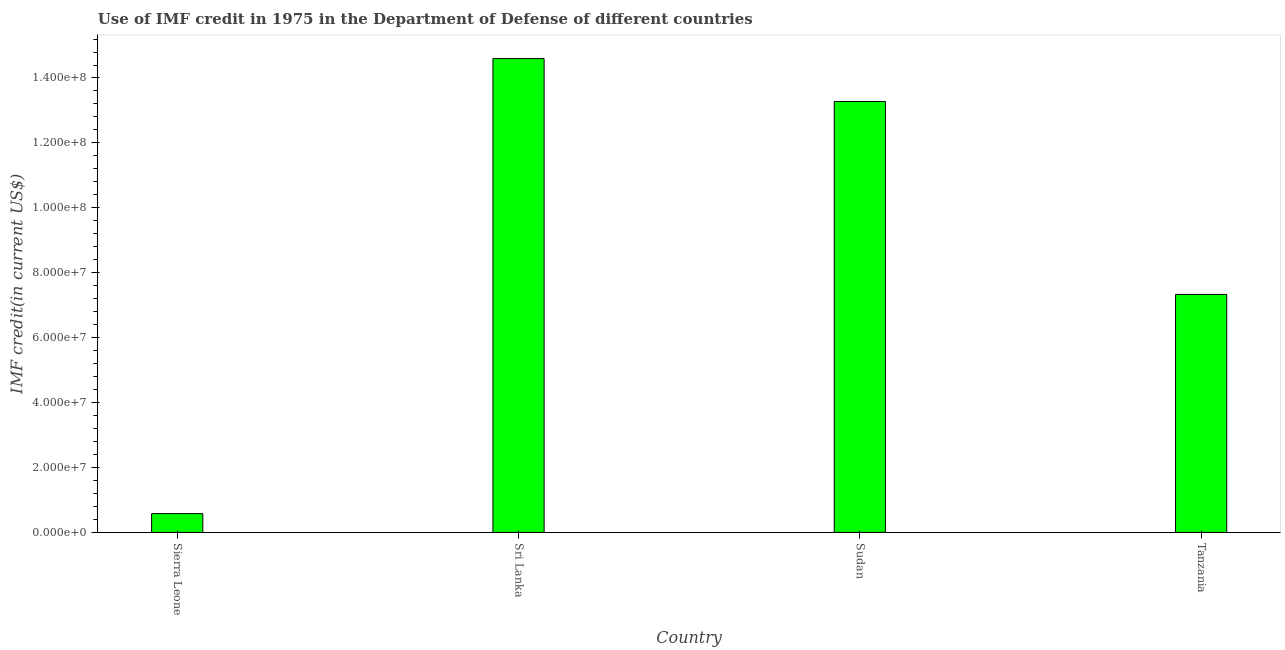Does the graph contain any zero values?
Keep it short and to the point. No. Does the graph contain grids?
Your answer should be very brief. No. What is the title of the graph?
Give a very brief answer. Use of IMF credit in 1975 in the Department of Defense of different countries. What is the label or title of the X-axis?
Make the answer very short. Country. What is the label or title of the Y-axis?
Your answer should be very brief. IMF credit(in current US$). What is the use of imf credit in dod in Sierra Leone?
Your answer should be very brief. 5.78e+06. Across all countries, what is the maximum use of imf credit in dod?
Your answer should be compact. 1.46e+08. Across all countries, what is the minimum use of imf credit in dod?
Offer a very short reply. 5.78e+06. In which country was the use of imf credit in dod maximum?
Your response must be concise. Sri Lanka. In which country was the use of imf credit in dod minimum?
Your answer should be compact. Sierra Leone. What is the sum of the use of imf credit in dod?
Provide a short and direct response. 3.58e+08. What is the difference between the use of imf credit in dod in Sudan and Tanzania?
Make the answer very short. 5.94e+07. What is the average use of imf credit in dod per country?
Ensure brevity in your answer.  8.95e+07. What is the median use of imf credit in dod?
Keep it short and to the point. 1.03e+08. What is the ratio of the use of imf credit in dod in Sierra Leone to that in Sudan?
Provide a succinct answer. 0.04. What is the difference between the highest and the second highest use of imf credit in dod?
Give a very brief answer. 1.32e+07. What is the difference between the highest and the lowest use of imf credit in dod?
Your answer should be compact. 1.40e+08. How many bars are there?
Keep it short and to the point. 4. Are all the bars in the graph horizontal?
Ensure brevity in your answer.  No. How many countries are there in the graph?
Give a very brief answer. 4. What is the difference between two consecutive major ticks on the Y-axis?
Provide a succinct answer. 2.00e+07. Are the values on the major ticks of Y-axis written in scientific E-notation?
Offer a very short reply. Yes. What is the IMF credit(in current US$) of Sierra Leone?
Make the answer very short. 5.78e+06. What is the IMF credit(in current US$) of Sri Lanka?
Your response must be concise. 1.46e+08. What is the IMF credit(in current US$) of Sudan?
Offer a very short reply. 1.33e+08. What is the IMF credit(in current US$) of Tanzania?
Provide a succinct answer. 7.33e+07. What is the difference between the IMF credit(in current US$) in Sierra Leone and Sri Lanka?
Ensure brevity in your answer.  -1.40e+08. What is the difference between the IMF credit(in current US$) in Sierra Leone and Sudan?
Give a very brief answer. -1.27e+08. What is the difference between the IMF credit(in current US$) in Sierra Leone and Tanzania?
Your answer should be very brief. -6.75e+07. What is the difference between the IMF credit(in current US$) in Sri Lanka and Sudan?
Your answer should be compact. 1.32e+07. What is the difference between the IMF credit(in current US$) in Sri Lanka and Tanzania?
Give a very brief answer. 7.27e+07. What is the difference between the IMF credit(in current US$) in Sudan and Tanzania?
Offer a terse response. 5.94e+07. What is the ratio of the IMF credit(in current US$) in Sierra Leone to that in Sri Lanka?
Give a very brief answer. 0.04. What is the ratio of the IMF credit(in current US$) in Sierra Leone to that in Sudan?
Make the answer very short. 0.04. What is the ratio of the IMF credit(in current US$) in Sierra Leone to that in Tanzania?
Provide a succinct answer. 0.08. What is the ratio of the IMF credit(in current US$) in Sri Lanka to that in Tanzania?
Make the answer very short. 1.99. What is the ratio of the IMF credit(in current US$) in Sudan to that in Tanzania?
Offer a very short reply. 1.81. 